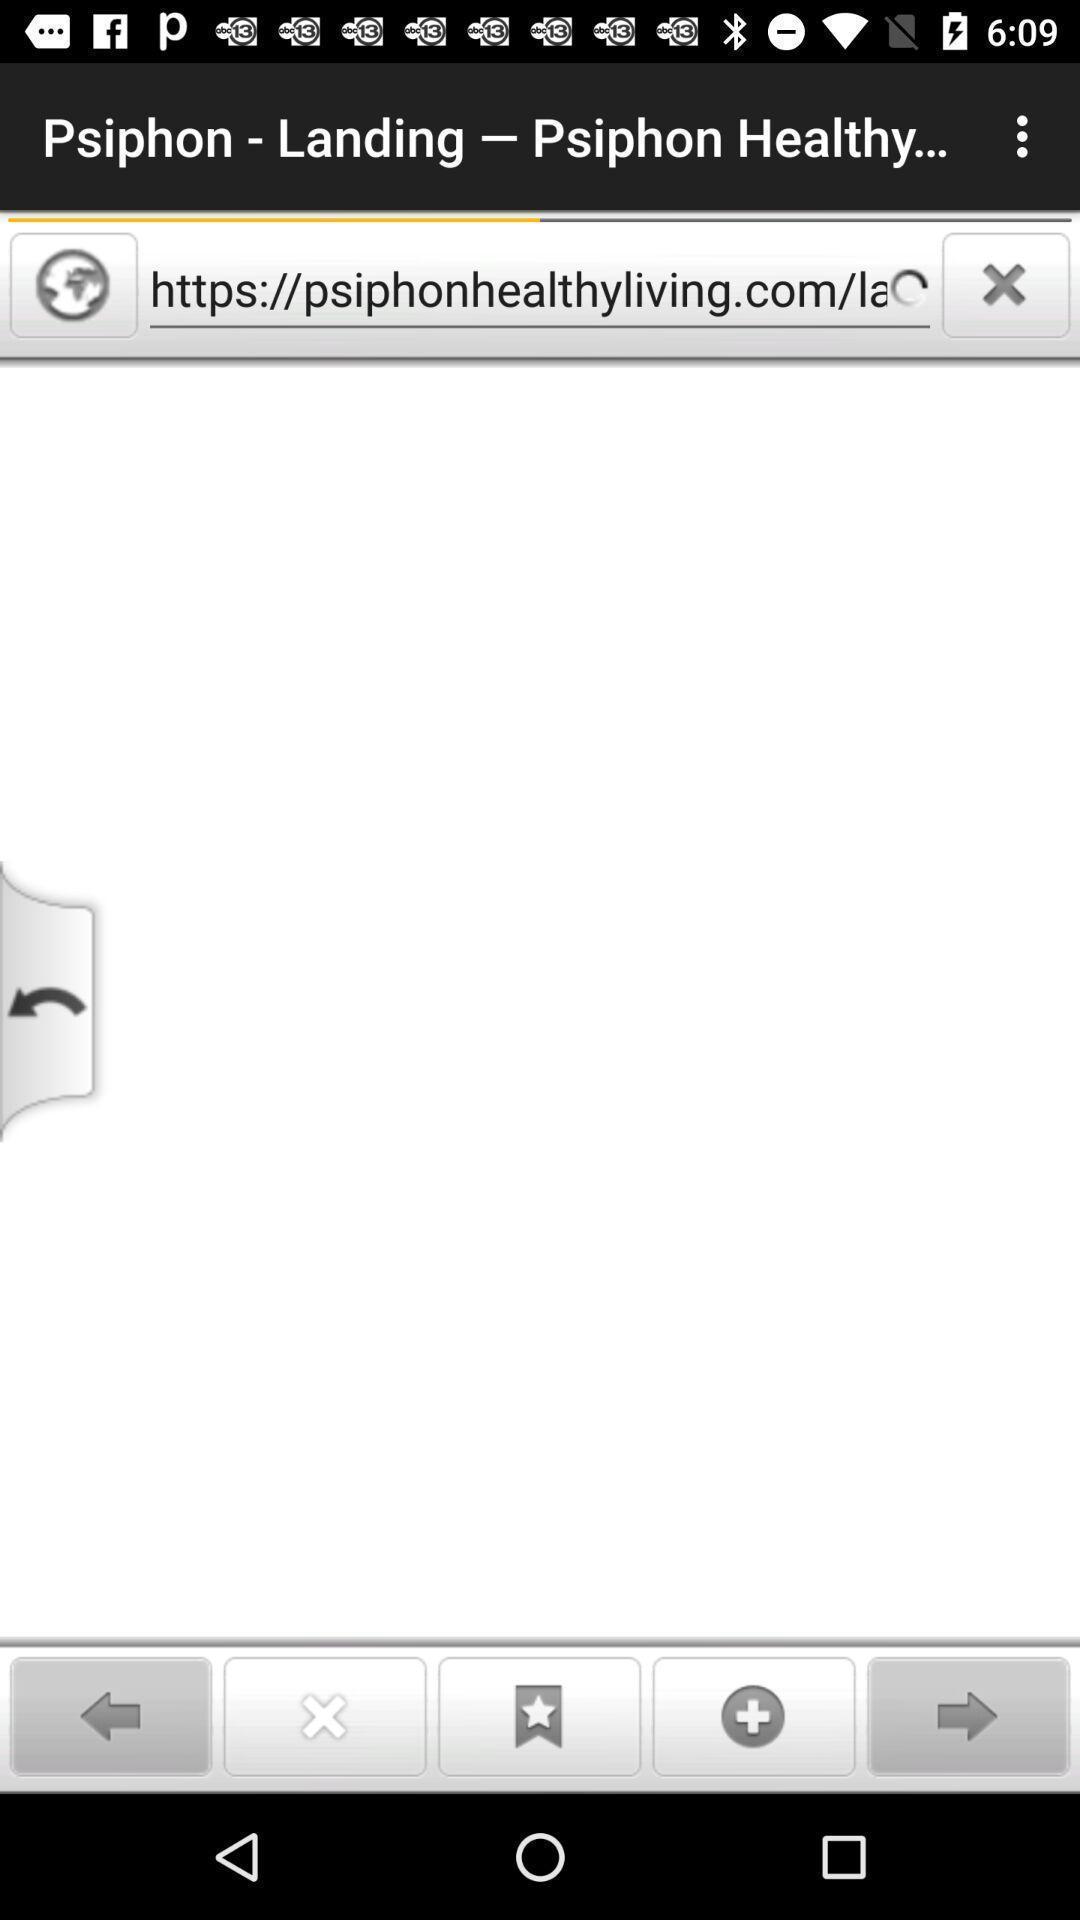Describe the key features of this screenshot. Screen displaying the loading page of a hyperlink. 